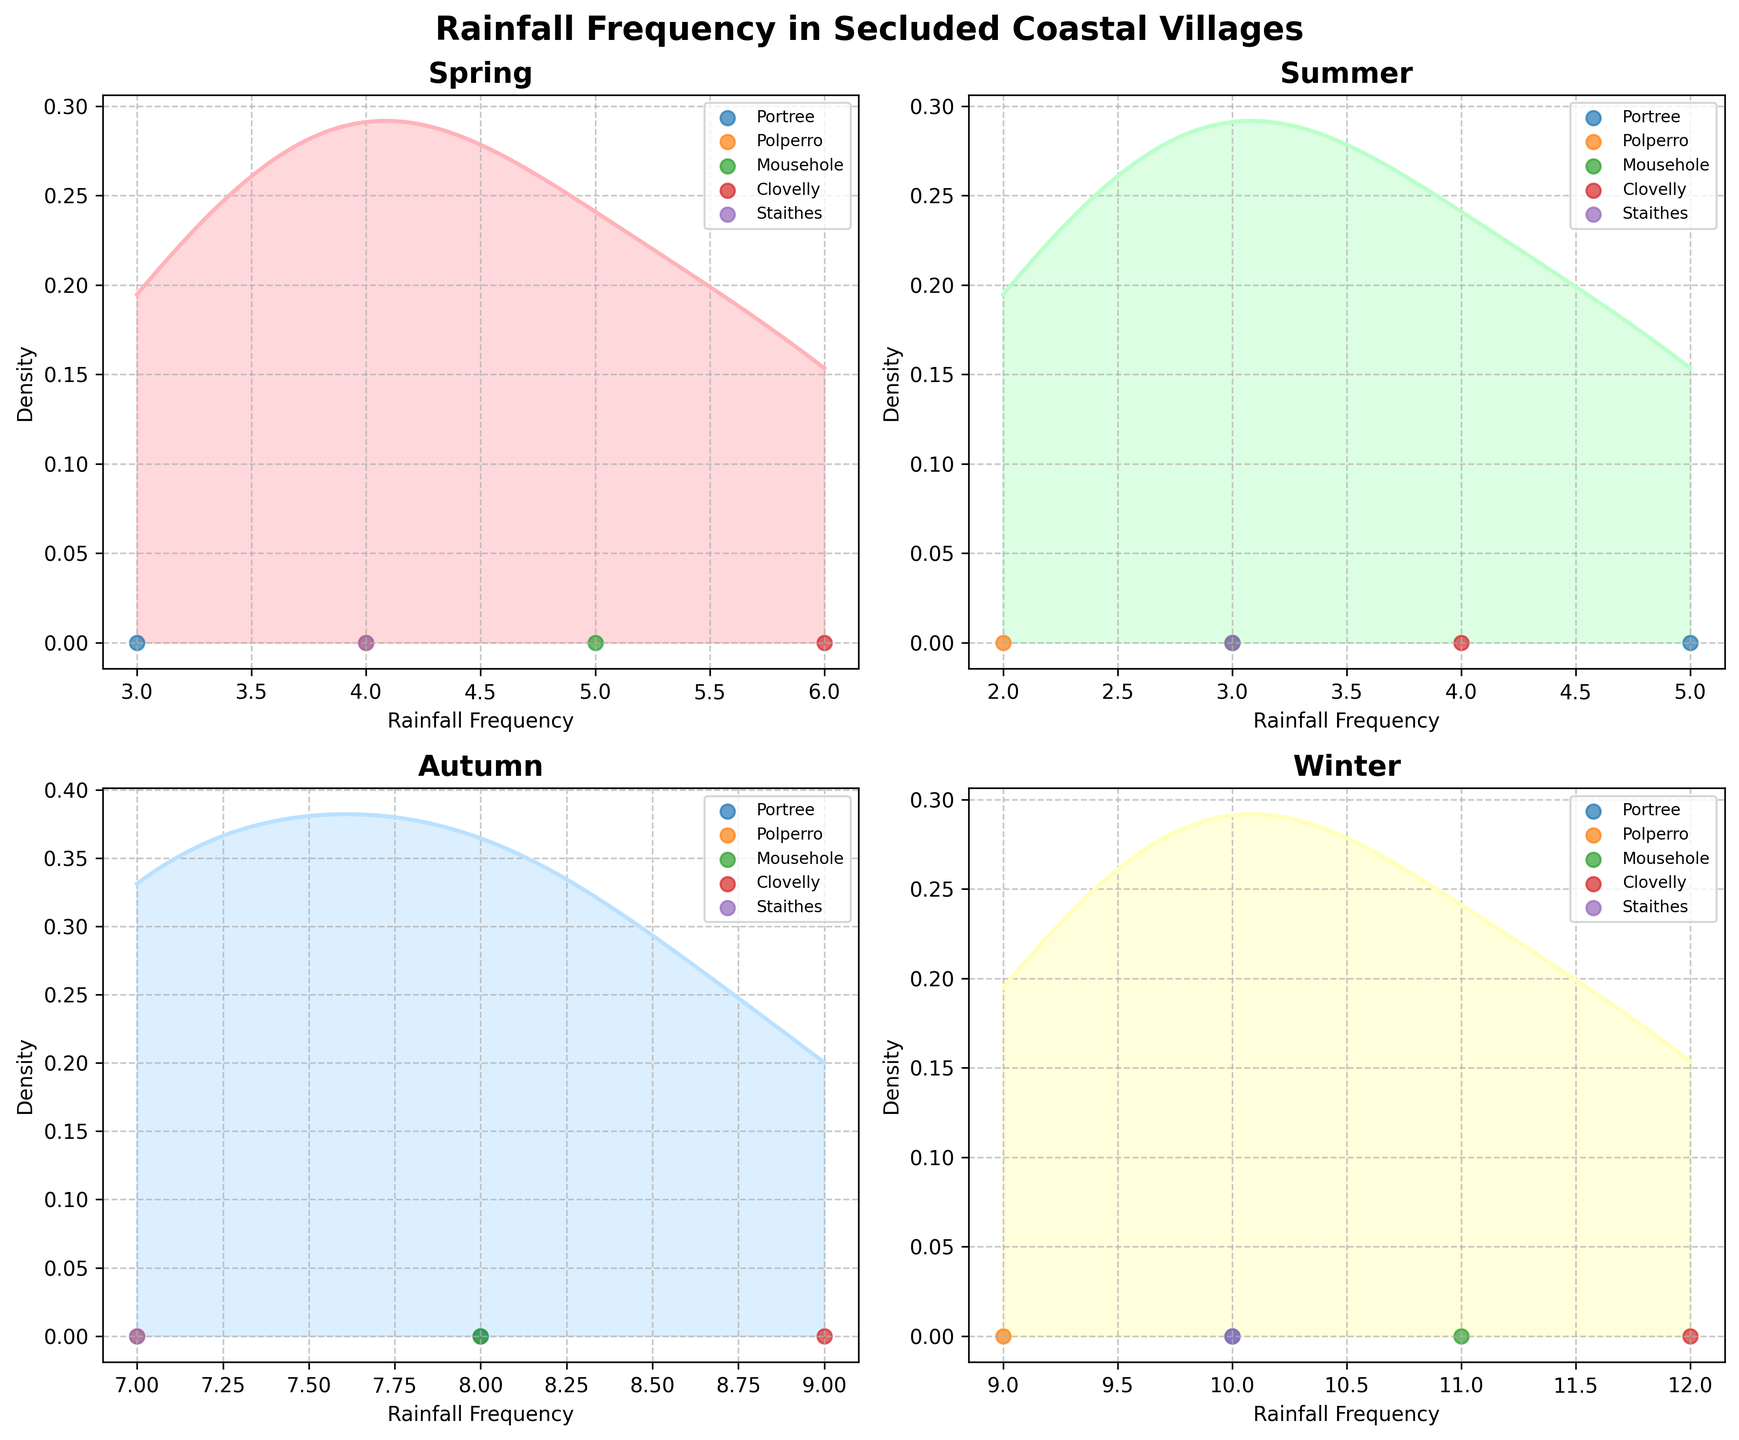How many seasons are shown in the figure and what are they? The figure includes four subplots, each titled with a specific season. The seasons are mentioned in the titles of each subplot. By counting these titles, we can list the seasons.
Answer: Four seasons: Spring, Summer, Autumn, and Winter Which village has the highest rainfall frequency in Winter? By examining the Winter subplot, we look for the village's point on the scatter plot with the highest x-axis value, which represents the rainfall frequency.
Answer: Clovelly What is the range of rainfall frequency values in Summer? In the Summer subplot, we reference the x-axis to identify the minimum and maximum rainfall frequency values scattered across the subplots. We then calculate the difference.
Answer: 2 to 5 Which season has the most dispersed rainfall frequency (widest range of values)? We observe each subplot's x-axis range to determine which one covers the widest span of rainfall frequency.
Answer: Winter Compare Spring and Autumn: Which season shows a higher average rainfall frequency? By examining the density curves' peak positions (where they are most concentrated) in the Spring and Autumn subplots, we estimate the average rainfall frequency. Autumn's peak is further to the right, indicating a higher average.
Answer: Autumn Which village has the least rainfall frequency in Spring? By checking the scatter points in the Spring subplot, we find the village with the lowest x-axis value, representing the lowest rainfall frequency.
Answer: Portree In which season is the rainfall frequency most uniformly distributed across the villages? We look at the density plots to see which season shows the flattest and broadest curve, indicating a more even distribution.
Answer: Spring How does the density plot shape in Autumn compare between Clovelly and the rest of the villages? We observe the scatter points and density plot shape in the Autumn subplot where the values for Clovelly are more concentrated towards the higher end, creating a skewed density plot compared to other villages.
Answer: Clovelly's values skew higher What is the overall trend of rainfall frequency throughout the year for Mousehole? By examining the scatter points for Mousehole across all subplots, we can trace its rainfall frequency from season to season. It increases from Spring to Winter with slight variations.
Answer: Increasing with variations Which season shows the most variation in data among the secluded coastal villages? We analyze the density plot shapes and spread of scatter points across all seasons. Winter shows the most variation with a wide spread of data points and a flatter density curve.
Answer: Winter 